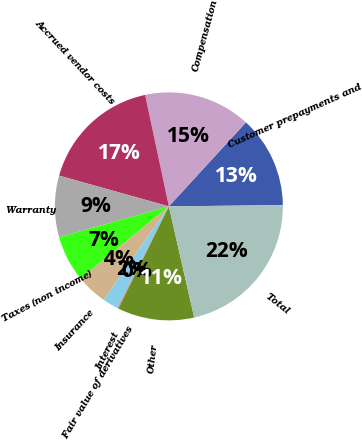Convert chart. <chart><loc_0><loc_0><loc_500><loc_500><pie_chart><fcel>Customer prepayments and<fcel>Compensation<fcel>Accrued vendor costs<fcel>Warranty<fcel>Taxes (non income)<fcel>Insurance<fcel>Fair value of derivatives<fcel>Interest<fcel>Other<fcel>Total<nl><fcel>13.01%<fcel>15.16%<fcel>17.31%<fcel>8.71%<fcel>6.56%<fcel>4.41%<fcel>2.26%<fcel>0.11%<fcel>10.86%<fcel>21.61%<nl></chart> 